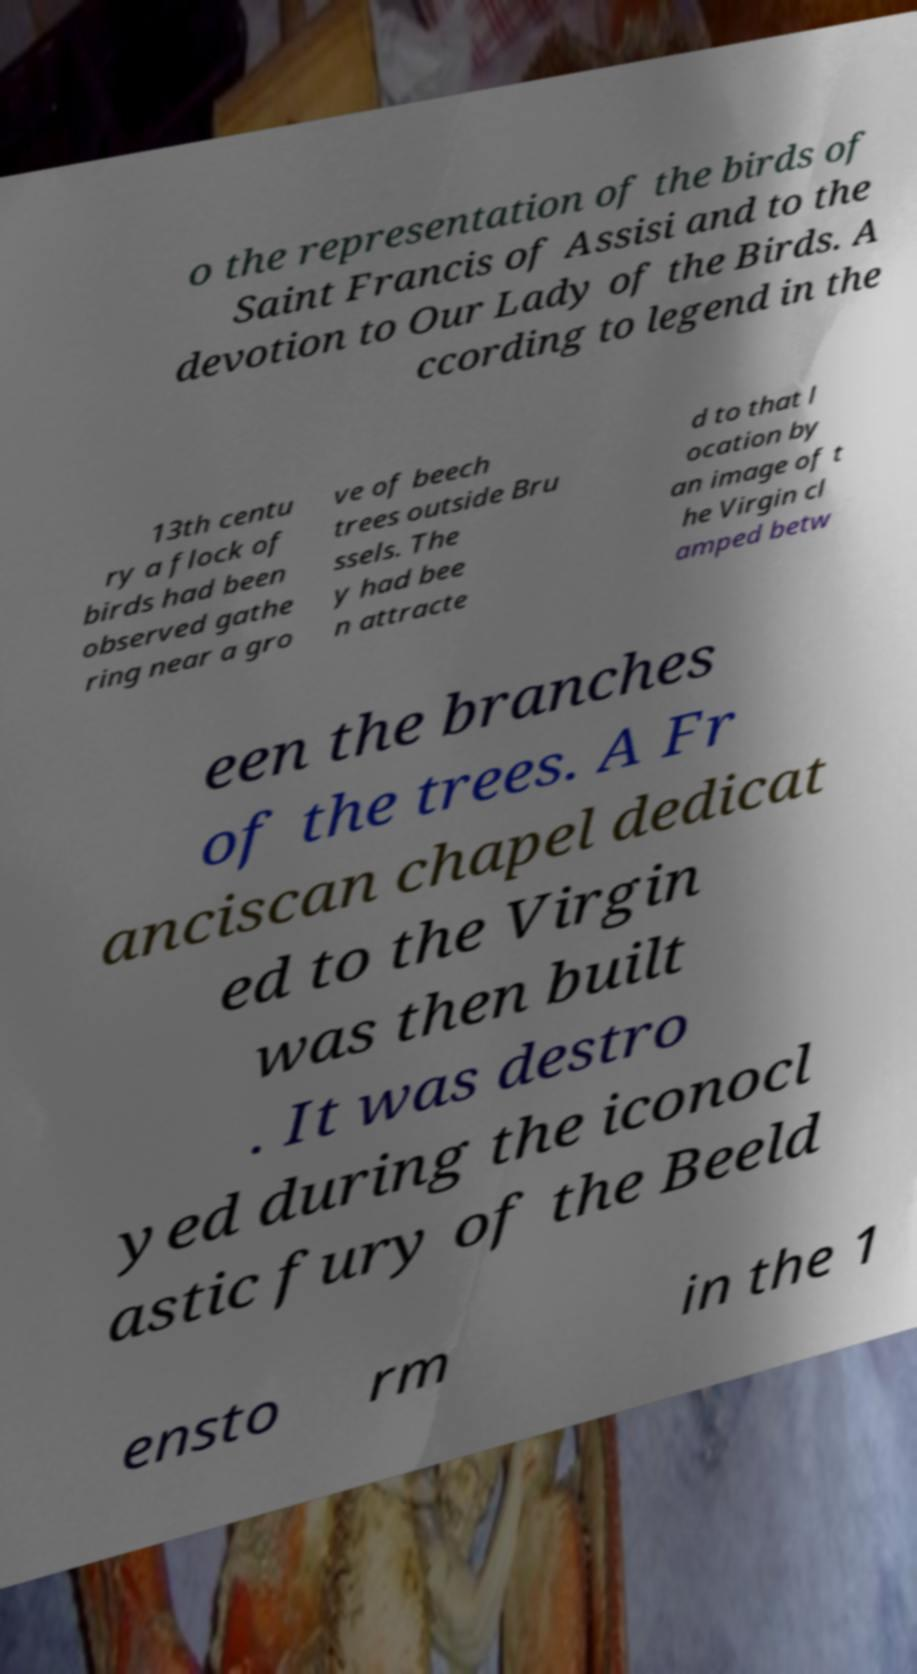Please identify and transcribe the text found in this image. o the representation of the birds of Saint Francis of Assisi and to the devotion to Our Lady of the Birds. A ccording to legend in the 13th centu ry a flock of birds had been observed gathe ring near a gro ve of beech trees outside Bru ssels. The y had bee n attracte d to that l ocation by an image of t he Virgin cl amped betw een the branches of the trees. A Fr anciscan chapel dedicat ed to the Virgin was then built . It was destro yed during the iconocl astic fury of the Beeld ensto rm in the 1 